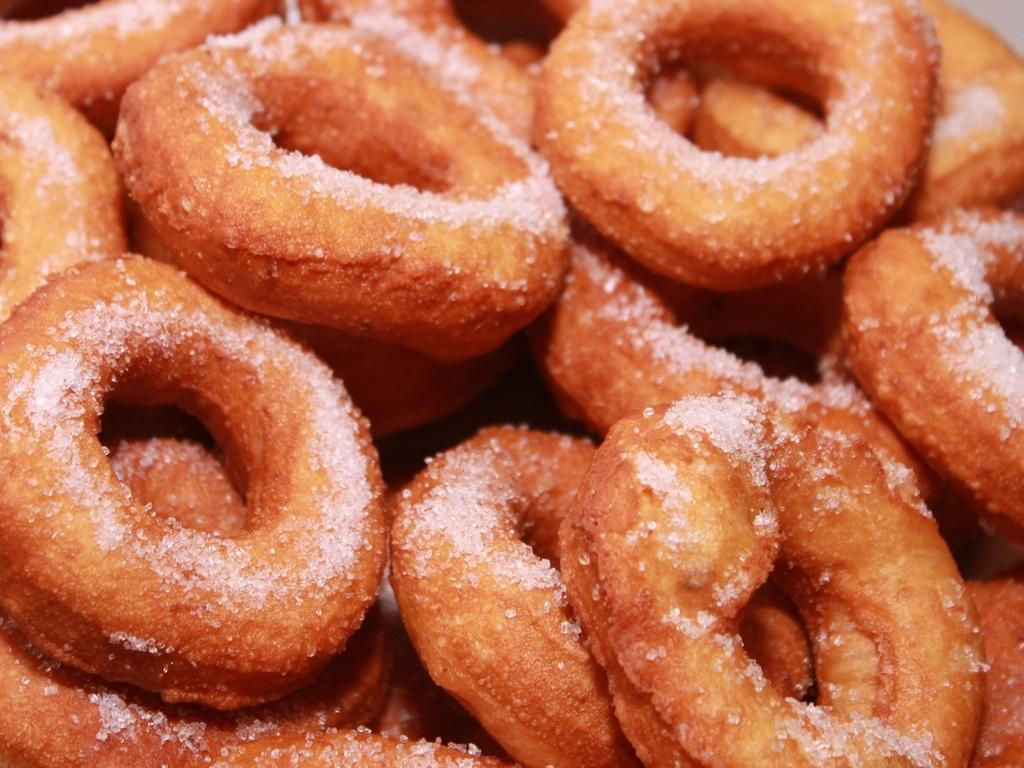What type of food is present in the image? There are doughnuts in the image. What kind of topping can be seen on the doughnuts? The doughnuts have sugar topping. Which team scored the winning goal at the end of the game in the image? There is no game or team present in the image; it only features doughnuts with sugar topping. 